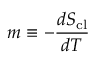<formula> <loc_0><loc_0><loc_500><loc_500>m \equiv - \frac { d S _ { c l } } { d T }</formula> 